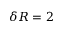<formula> <loc_0><loc_0><loc_500><loc_500>\delta R = 2</formula> 